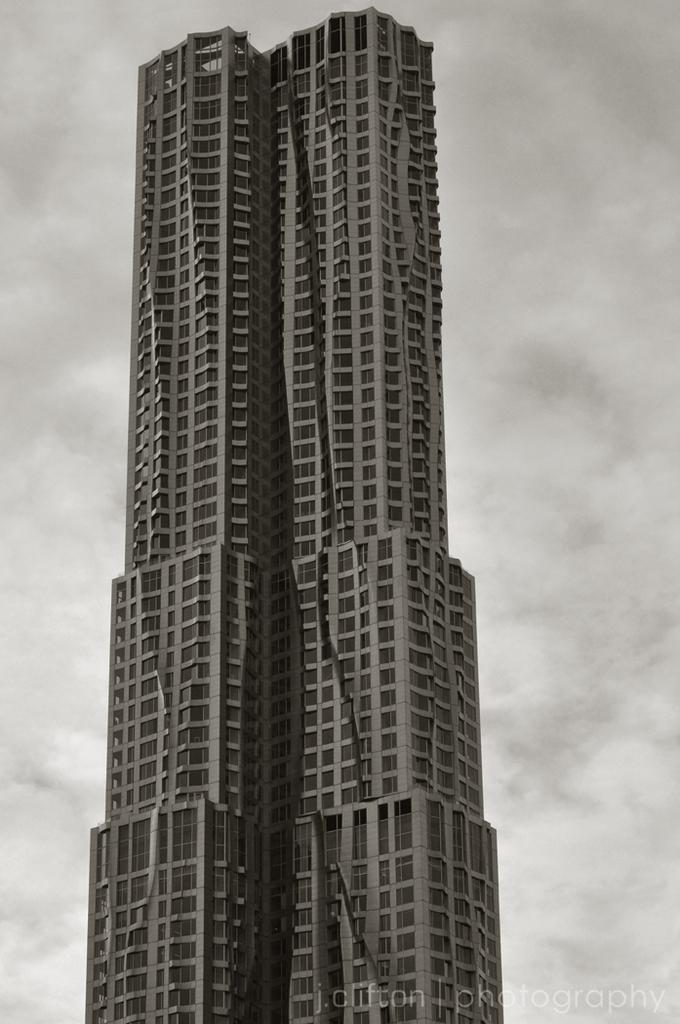What type of building is in the image? There is a skyscraper in the image. What can be seen in the background of the image? The sky is visible in the image. What is the condition of the sky in the image? Clouds are present in the sky. Where is the secretary located in the image? There is no secretary present in the image. What type of lamp can be seen illuminating the downtown area in the image? There is no downtown area or lamp present in the image. 